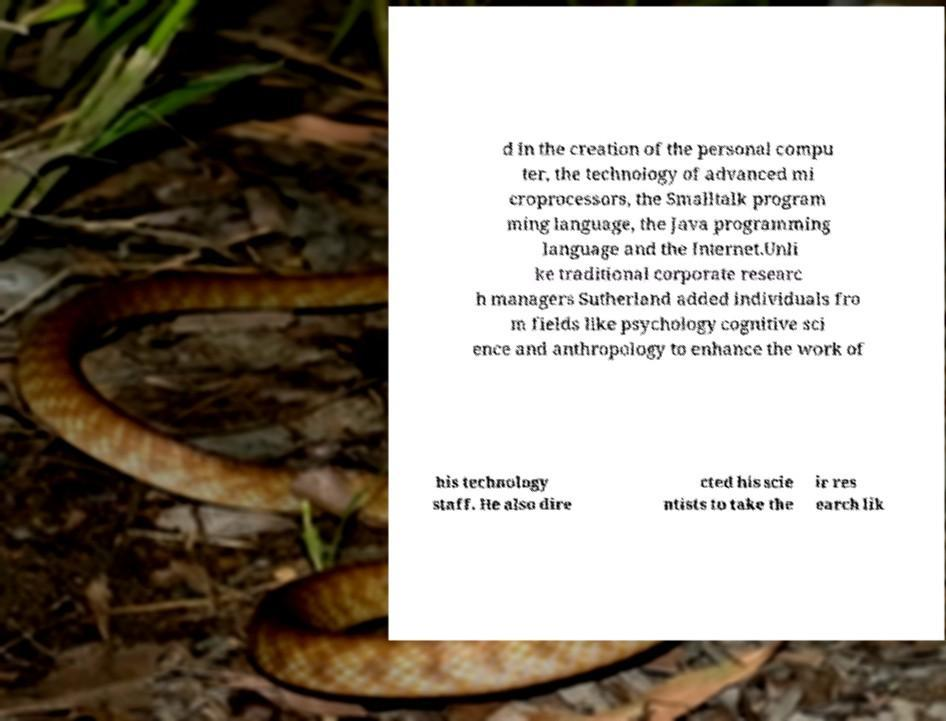Could you assist in decoding the text presented in this image and type it out clearly? d in the creation of the personal compu ter, the technology of advanced mi croprocessors, the Smalltalk program ming language, the Java programming language and the Internet.Unli ke traditional corporate researc h managers Sutherland added individuals fro m fields like psychology cognitive sci ence and anthropology to enhance the work of his technology staff. He also dire cted his scie ntists to take the ir res earch lik 